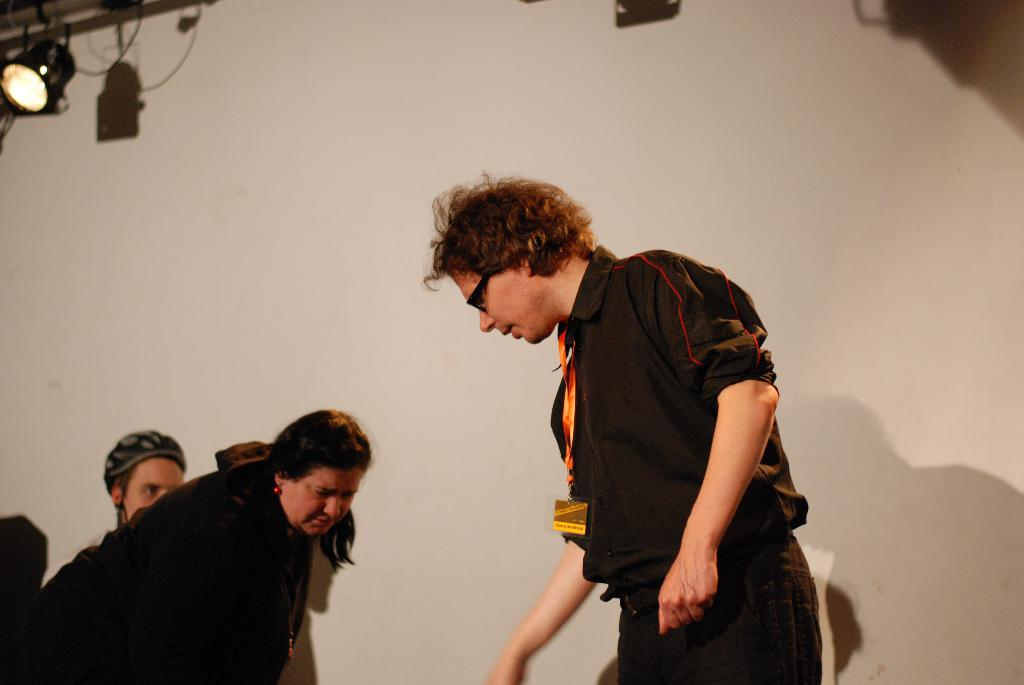What can be seen in the image? There are people in the image, including a man who is standing among them. Can you describe the man in the image? The man is wearing spectacles. What is visible in the background of the image? There is a wall and a stage light in the background of the image. What is the smell of the coast in the image? There is no mention of a coast or any smell in the image; it features people, a man with spectacles, and a wall with a stage light in the background. 